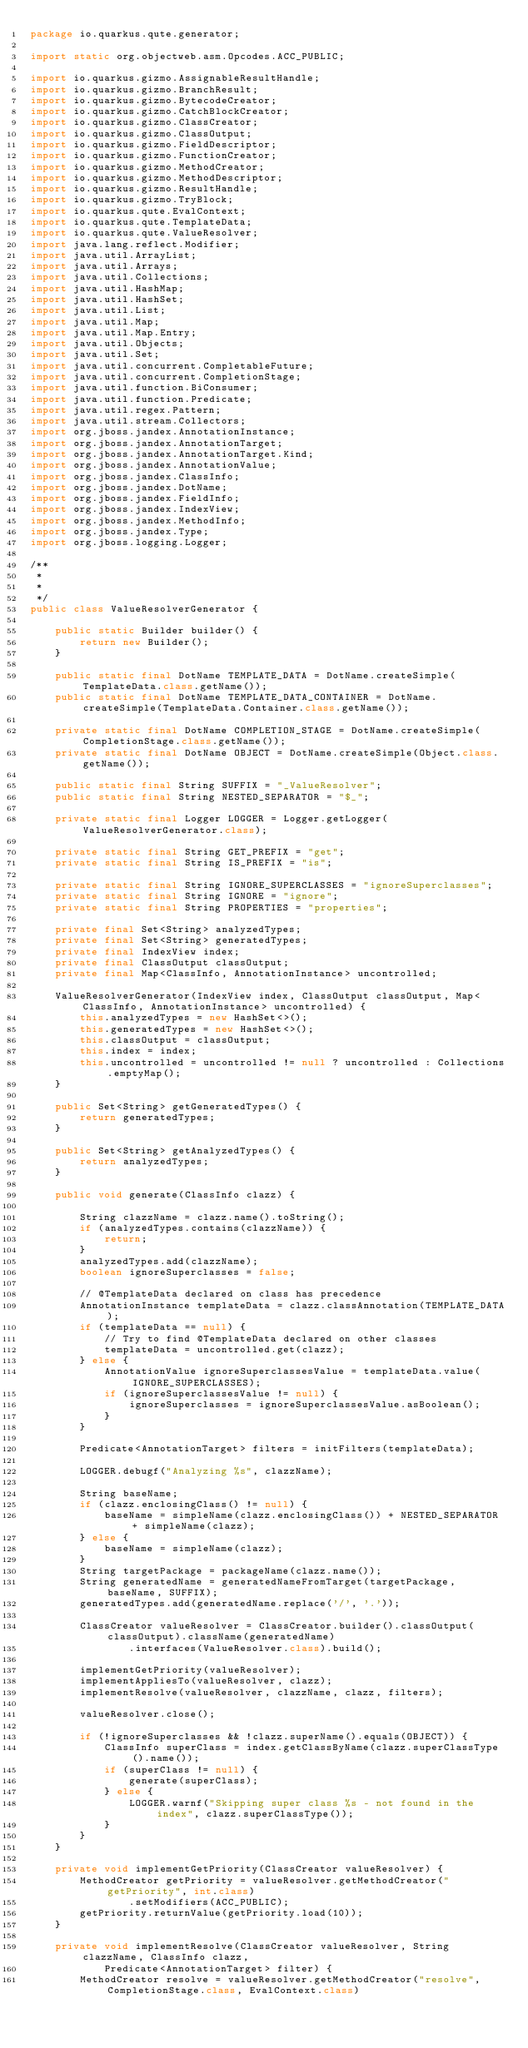<code> <loc_0><loc_0><loc_500><loc_500><_Java_>package io.quarkus.qute.generator;

import static org.objectweb.asm.Opcodes.ACC_PUBLIC;

import io.quarkus.gizmo.AssignableResultHandle;
import io.quarkus.gizmo.BranchResult;
import io.quarkus.gizmo.BytecodeCreator;
import io.quarkus.gizmo.CatchBlockCreator;
import io.quarkus.gizmo.ClassCreator;
import io.quarkus.gizmo.ClassOutput;
import io.quarkus.gizmo.FieldDescriptor;
import io.quarkus.gizmo.FunctionCreator;
import io.quarkus.gizmo.MethodCreator;
import io.quarkus.gizmo.MethodDescriptor;
import io.quarkus.gizmo.ResultHandle;
import io.quarkus.gizmo.TryBlock;
import io.quarkus.qute.EvalContext;
import io.quarkus.qute.TemplateData;
import io.quarkus.qute.ValueResolver;
import java.lang.reflect.Modifier;
import java.util.ArrayList;
import java.util.Arrays;
import java.util.Collections;
import java.util.HashMap;
import java.util.HashSet;
import java.util.List;
import java.util.Map;
import java.util.Map.Entry;
import java.util.Objects;
import java.util.Set;
import java.util.concurrent.CompletableFuture;
import java.util.concurrent.CompletionStage;
import java.util.function.BiConsumer;
import java.util.function.Predicate;
import java.util.regex.Pattern;
import java.util.stream.Collectors;
import org.jboss.jandex.AnnotationInstance;
import org.jboss.jandex.AnnotationTarget;
import org.jboss.jandex.AnnotationTarget.Kind;
import org.jboss.jandex.AnnotationValue;
import org.jboss.jandex.ClassInfo;
import org.jboss.jandex.DotName;
import org.jboss.jandex.FieldInfo;
import org.jboss.jandex.IndexView;
import org.jboss.jandex.MethodInfo;
import org.jboss.jandex.Type;
import org.jboss.logging.Logger;

/**
 * 
 * 
 */
public class ValueResolverGenerator {

    public static Builder builder() {
        return new Builder();
    }

    public static final DotName TEMPLATE_DATA = DotName.createSimple(TemplateData.class.getName());
    public static final DotName TEMPLATE_DATA_CONTAINER = DotName.createSimple(TemplateData.Container.class.getName());

    private static final DotName COMPLETION_STAGE = DotName.createSimple(CompletionStage.class.getName());
    private static final DotName OBJECT = DotName.createSimple(Object.class.getName());

    public static final String SUFFIX = "_ValueResolver";
    public static final String NESTED_SEPARATOR = "$_";

    private static final Logger LOGGER = Logger.getLogger(ValueResolverGenerator.class);

    private static final String GET_PREFIX = "get";
    private static final String IS_PREFIX = "is";

    private static final String IGNORE_SUPERCLASSES = "ignoreSuperclasses";
    private static final String IGNORE = "ignore";
    private static final String PROPERTIES = "properties";

    private final Set<String> analyzedTypes;
    private final Set<String> generatedTypes;
    private final IndexView index;
    private final ClassOutput classOutput;
    private final Map<ClassInfo, AnnotationInstance> uncontrolled;

    ValueResolverGenerator(IndexView index, ClassOutput classOutput, Map<ClassInfo, AnnotationInstance> uncontrolled) {
        this.analyzedTypes = new HashSet<>();
        this.generatedTypes = new HashSet<>();
        this.classOutput = classOutput;
        this.index = index;
        this.uncontrolled = uncontrolled != null ? uncontrolled : Collections.emptyMap();
    }

    public Set<String> getGeneratedTypes() {
        return generatedTypes;
    }

    public Set<String> getAnalyzedTypes() {
        return analyzedTypes;
    }

    public void generate(ClassInfo clazz) {

        String clazzName = clazz.name().toString();
        if (analyzedTypes.contains(clazzName)) {
            return;
        }
        analyzedTypes.add(clazzName);
        boolean ignoreSuperclasses = false;

        // @TemplateData declared on class has precedence
        AnnotationInstance templateData = clazz.classAnnotation(TEMPLATE_DATA);
        if (templateData == null) {
            // Try to find @TemplateData declared on other classes
            templateData = uncontrolled.get(clazz);
        } else {
            AnnotationValue ignoreSuperclassesValue = templateData.value(IGNORE_SUPERCLASSES);
            if (ignoreSuperclassesValue != null) {
                ignoreSuperclasses = ignoreSuperclassesValue.asBoolean();
            }
        }

        Predicate<AnnotationTarget> filters = initFilters(templateData);

        LOGGER.debugf("Analyzing %s", clazzName);

        String baseName;
        if (clazz.enclosingClass() != null) {
            baseName = simpleName(clazz.enclosingClass()) + NESTED_SEPARATOR + simpleName(clazz);
        } else {
            baseName = simpleName(clazz);
        }
        String targetPackage = packageName(clazz.name());
        String generatedName = generatedNameFromTarget(targetPackage, baseName, SUFFIX);
        generatedTypes.add(generatedName.replace('/', '.'));

        ClassCreator valueResolver = ClassCreator.builder().classOutput(classOutput).className(generatedName)
                .interfaces(ValueResolver.class).build();

        implementGetPriority(valueResolver);
        implementAppliesTo(valueResolver, clazz);
        implementResolve(valueResolver, clazzName, clazz, filters);

        valueResolver.close();

        if (!ignoreSuperclasses && !clazz.superName().equals(OBJECT)) {
            ClassInfo superClass = index.getClassByName(clazz.superClassType().name());
            if (superClass != null) {
                generate(superClass);
            } else {
                LOGGER.warnf("Skipping super class %s - not found in the index", clazz.superClassType());
            }
        }
    }

    private void implementGetPriority(ClassCreator valueResolver) {
        MethodCreator getPriority = valueResolver.getMethodCreator("getPriority", int.class)
                .setModifiers(ACC_PUBLIC);
        getPriority.returnValue(getPriority.load(10));
    }

    private void implementResolve(ClassCreator valueResolver, String clazzName, ClassInfo clazz,
            Predicate<AnnotationTarget> filter) {
        MethodCreator resolve = valueResolver.getMethodCreator("resolve", CompletionStage.class, EvalContext.class)</code> 